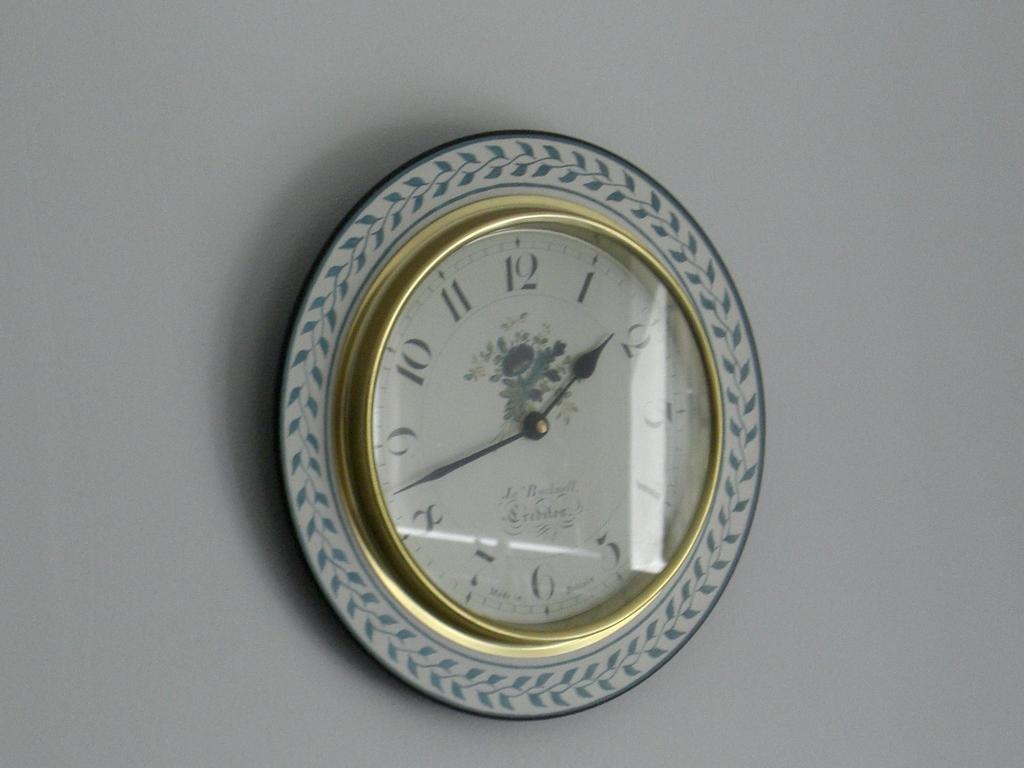Provide a one-sentence caption for the provided image. A fancy wall clock with the time showing 1:43. 